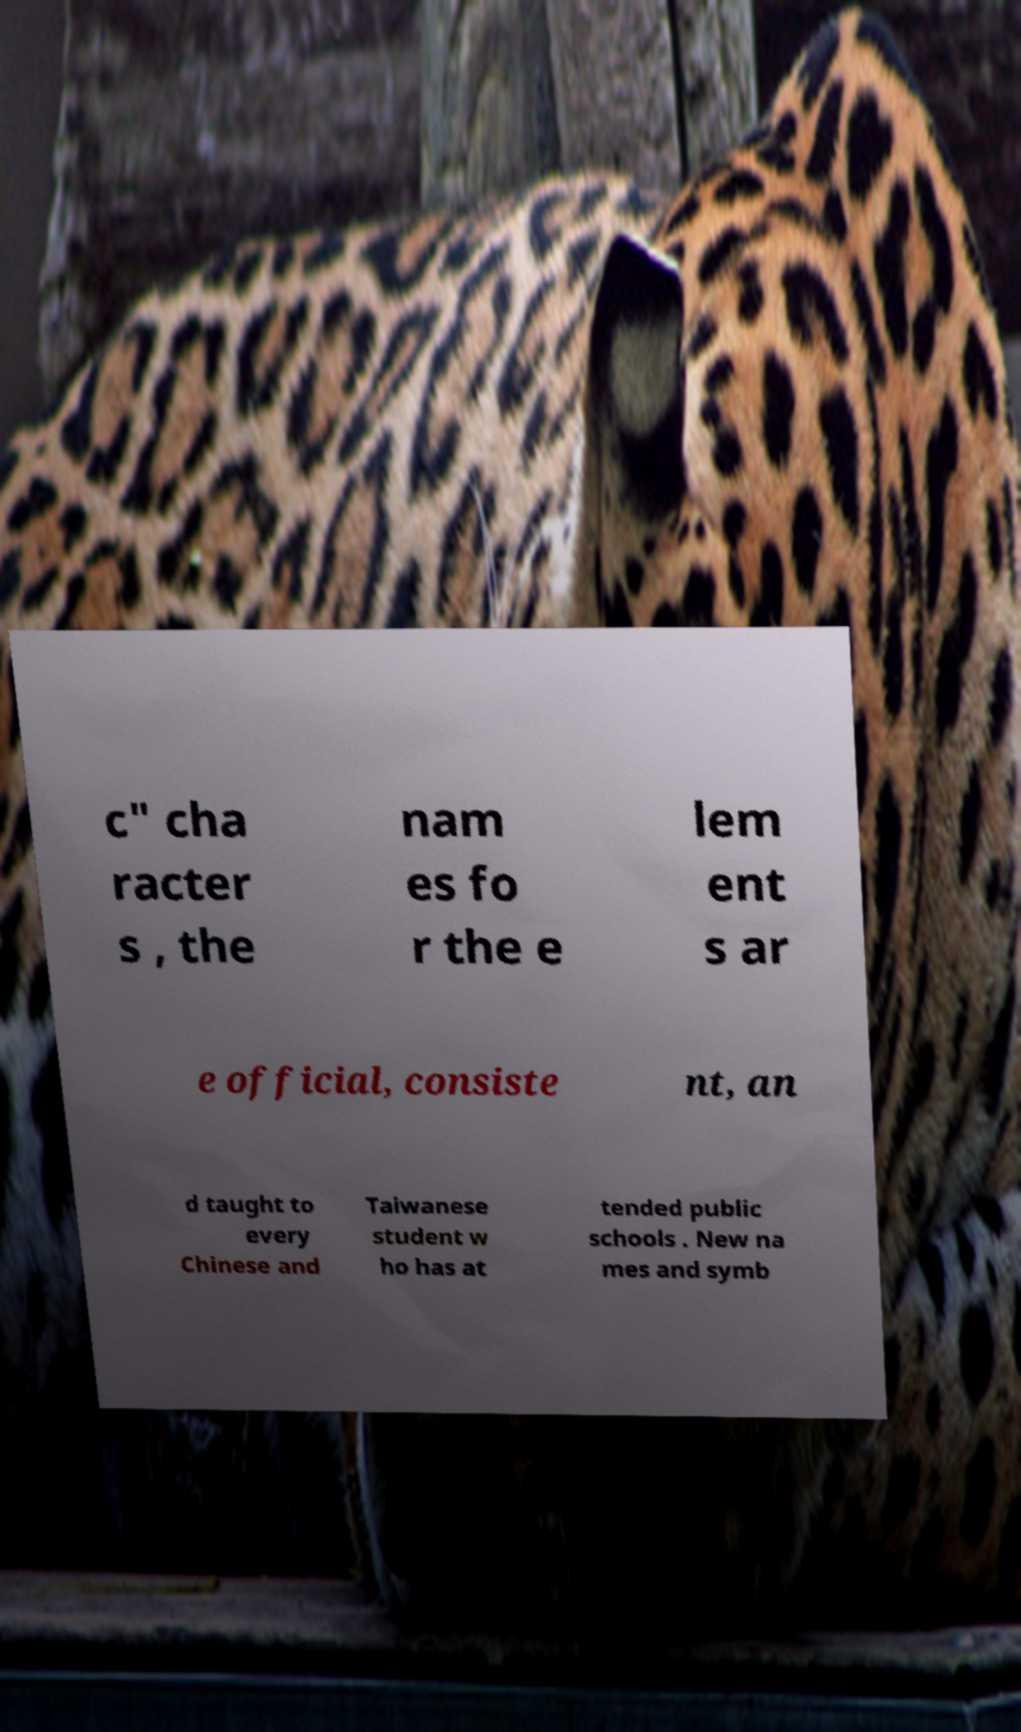Could you extract and type out the text from this image? c" cha racter s , the nam es fo r the e lem ent s ar e official, consiste nt, an d taught to every Chinese and Taiwanese student w ho has at tended public schools . New na mes and symb 